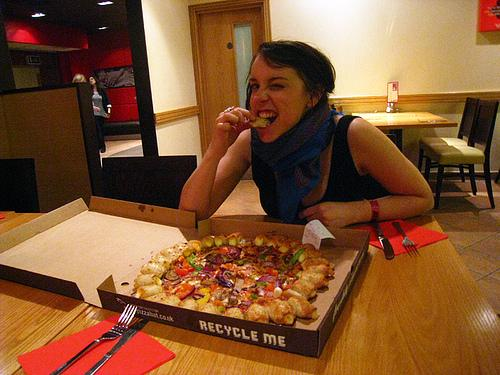Which item here can be turned into something else without eating it?

Choices:
A) pizza
B) nothing
C) pizza box
D) woman pizza box 